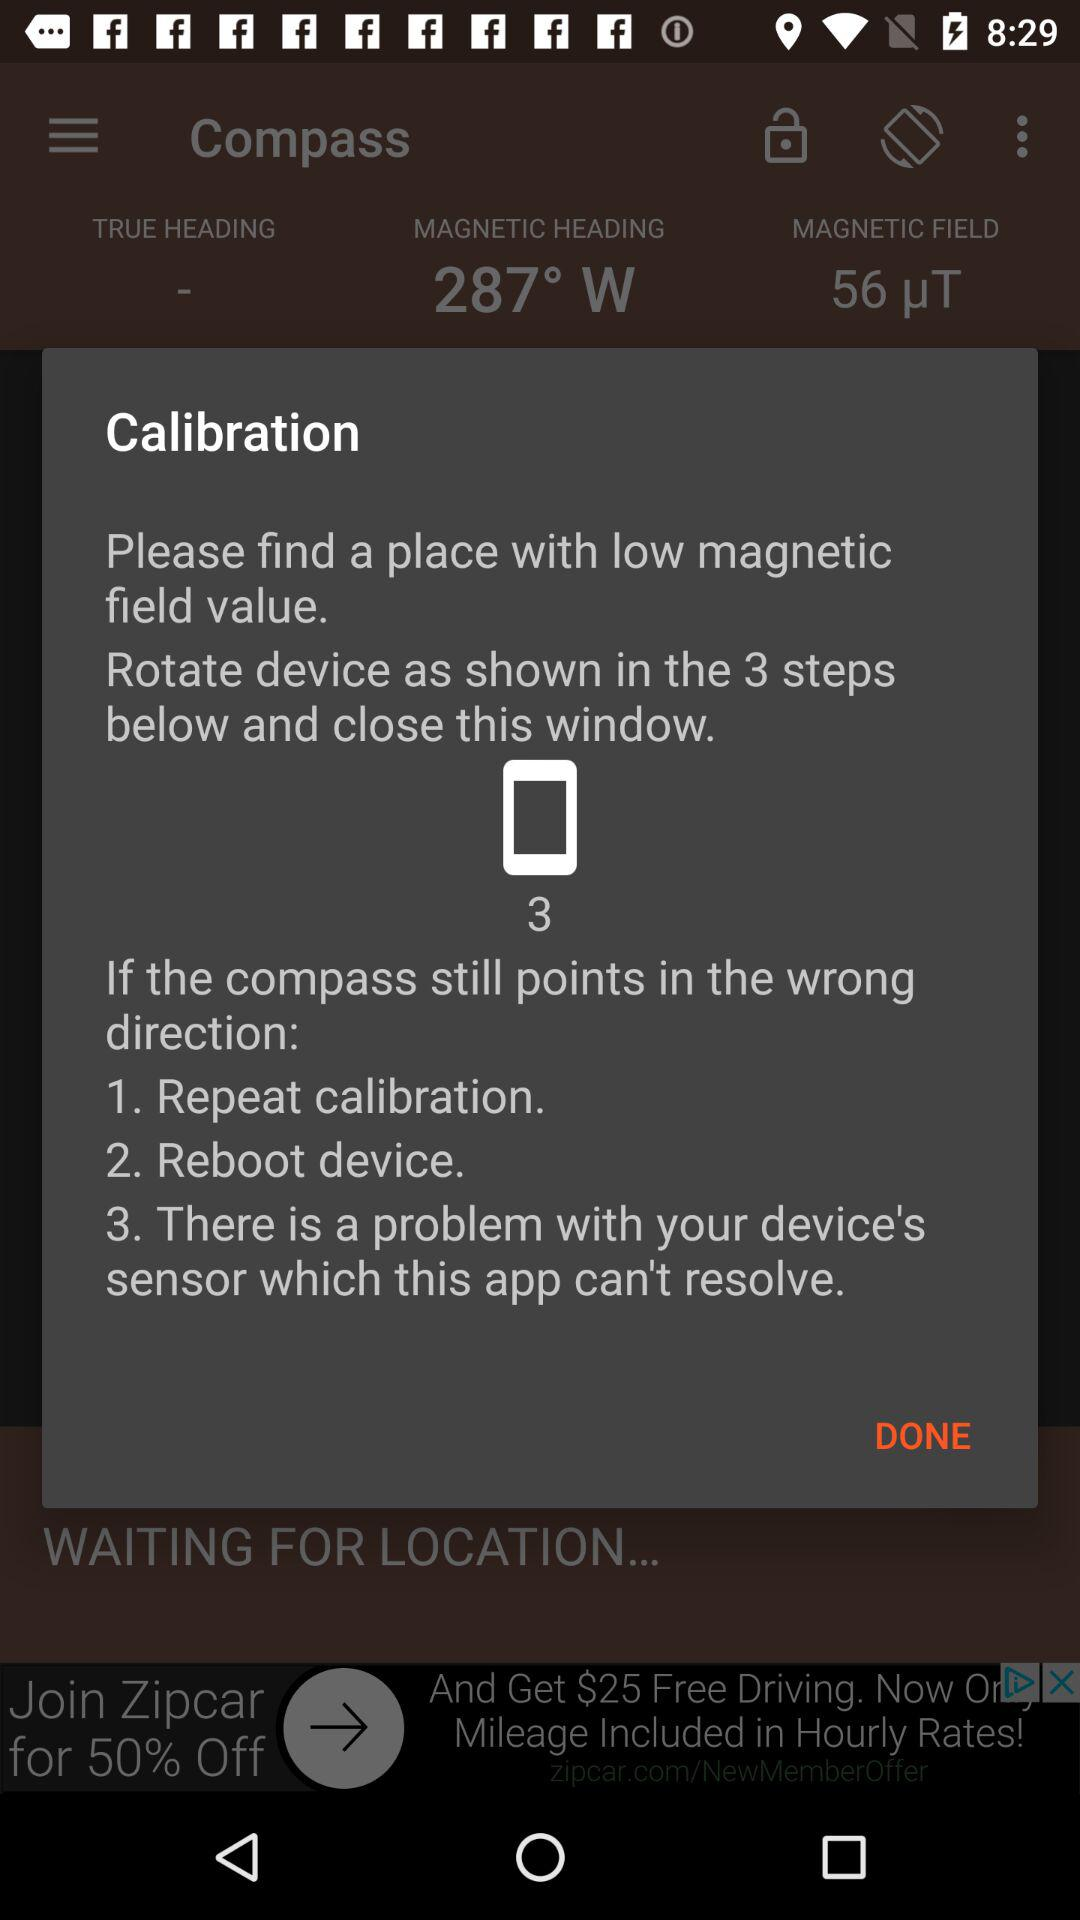What is the value of the magnetic field? The value of the magnetic field is 56 μT. 